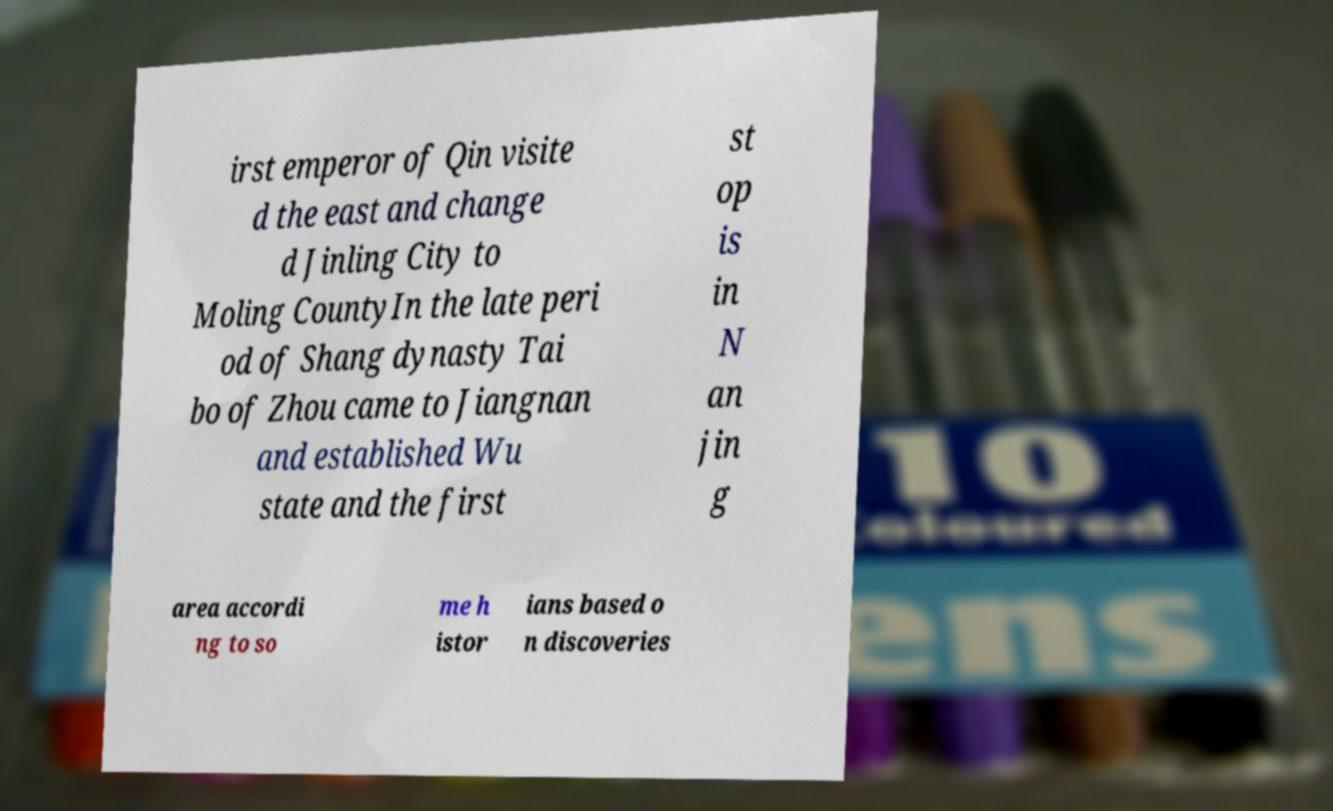Could you extract and type out the text from this image? irst emperor of Qin visite d the east and change d Jinling City to Moling CountyIn the late peri od of Shang dynasty Tai bo of Zhou came to Jiangnan and established Wu state and the first st op is in N an jin g area accordi ng to so me h istor ians based o n discoveries 